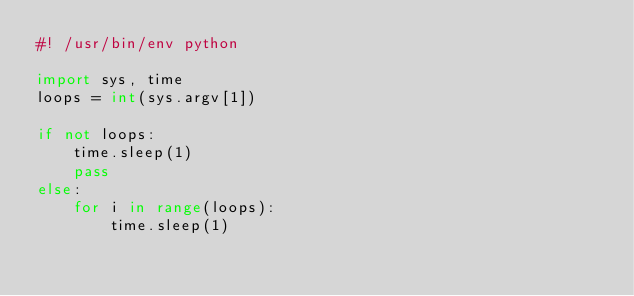Convert code to text. <code><loc_0><loc_0><loc_500><loc_500><_Python_>#! /usr/bin/env python

import sys, time
loops = int(sys.argv[1])

if not loops:
	time.sleep(1)
	pass
else:
	for i in range(loops):
		time.sleep(1)

</code> 